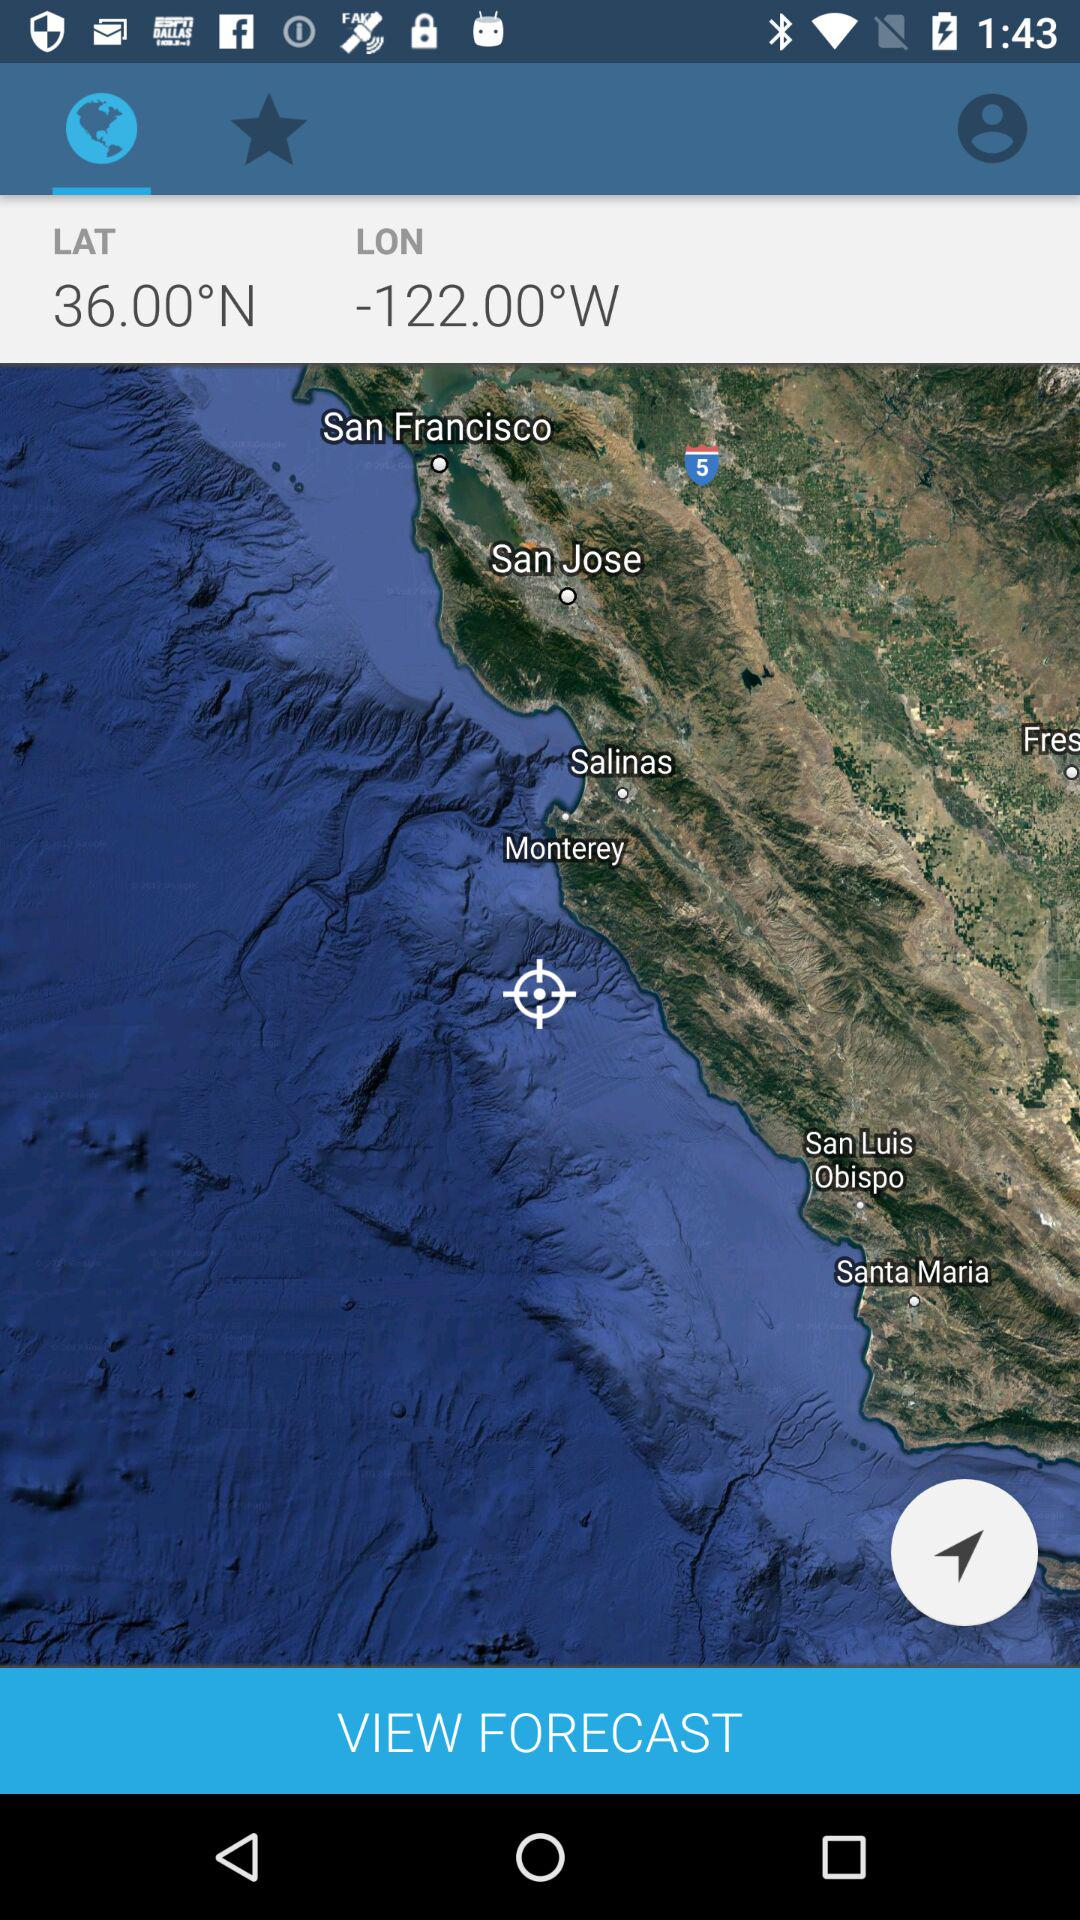Will it be cloudy again tomorrow?
When the provided information is insufficient, respond with <no answer>. <no answer> 